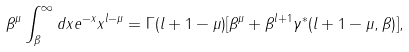Convert formula to latex. <formula><loc_0><loc_0><loc_500><loc_500>\beta ^ { \mu } \int _ { \beta } ^ { \infty } d x e ^ { - x } x ^ { l - \mu } = \Gamma ( l + 1 - \mu ) [ \beta ^ { \mu } + \beta ^ { l + 1 } \gamma ^ { * } ( l + 1 - \mu , \beta ) ] ,</formula> 